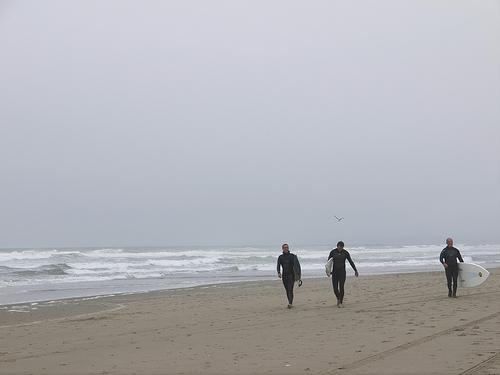Question: who is in the picture?
Choices:
A. Skaters.
B. Surfers.
C. Golfers.
D. Players.
Answer with the letter. Answer: B Question: why are the men at the beach?
Choices:
A. To sunbathe.
B. To play frisbee.
C. To surf.
D. To fly kites.
Answer with the letter. Answer: C Question: what are the men wearing?
Choices:
A. Black wetsuits.
B. Shorts.
C. Jeans.
D. Suits.
Answer with the letter. Answer: A Question: how many men are there?
Choices:
A. 4.
B. 3.
C. 5.
D. 6.
Answer with the letter. Answer: B Question: what are the men carrying?
Choices:
A. Skateboards.
B. Snowboards.
C. Surfboards.
D. Skiis.
Answer with the letter. Answer: C Question: what is in the background?
Choices:
A. Trees.
B. The field.
C. The buildings.
D. The water.
Answer with the letter. Answer: D 